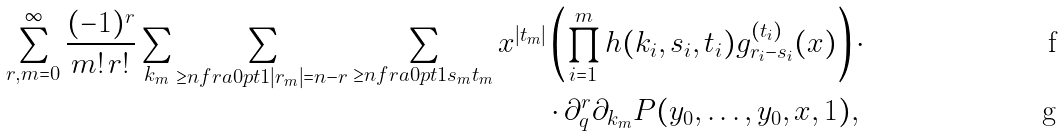Convert formula to latex. <formula><loc_0><loc_0><loc_500><loc_500>\sum _ { r , m = 0 } ^ { \infty } \frac { ( - 1 ) ^ { r } } { m ! \, r ! } \sum _ { { k } _ { m } } \sum _ { \geq n f r a { } { 0 p t } { 1 } { | { r } _ { m } | } { = n - r } } \sum _ { \geq n f r a { } { 0 p t } { 1 } { { s } _ { m } } { { t } _ { m } } } x ^ { | { t } _ { m } | } & \left ( \prod _ { i = 1 } ^ { m } h ( k _ { i } , s _ { i } , t _ { i } ) g _ { r _ { i } - s _ { i } } ^ { ( t _ { i } ) } ( x ) \right ) \cdot \\ & \cdot \partial _ { q } ^ { r } \partial _ { { k } _ { m } } P ( y _ { 0 } , \dots , y _ { 0 } , x , 1 ) ,</formula> 